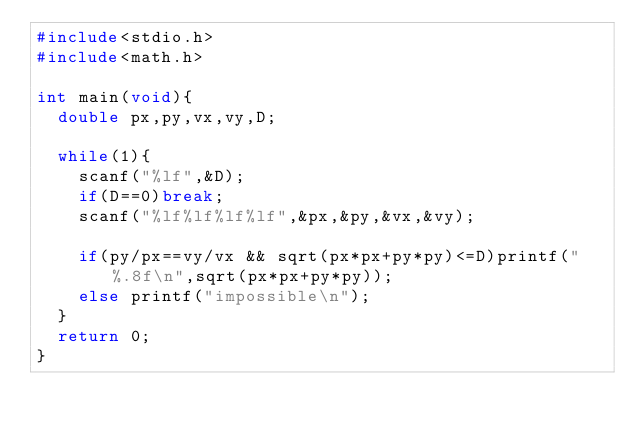<code> <loc_0><loc_0><loc_500><loc_500><_C_>#include<stdio.h>
#include<math.h>

int main(void){
  double px,py,vx,vy,D;

  while(1){
    scanf("%lf",&D);
    if(D==0)break;
    scanf("%lf%lf%lf%lf",&px,&py,&vx,&vy);

    if(py/px==vy/vx && sqrt(px*px+py*py)<=D)printf("%.8f\n",sqrt(px*px+py*py));
    else printf("impossible\n");
  }
  return 0;
}</code> 